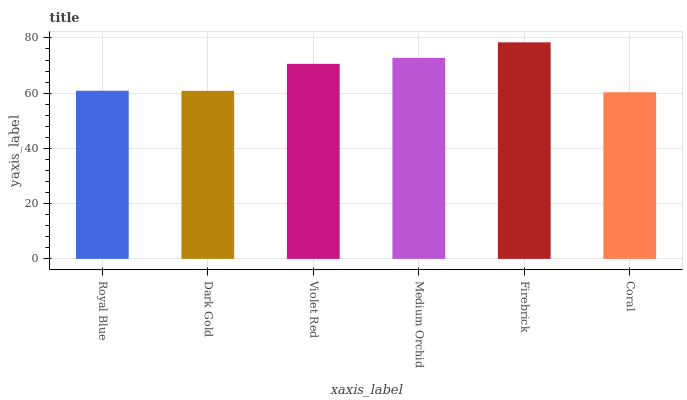Is Coral the minimum?
Answer yes or no. Yes. Is Firebrick the maximum?
Answer yes or no. Yes. Is Dark Gold the minimum?
Answer yes or no. No. Is Dark Gold the maximum?
Answer yes or no. No. Is Royal Blue greater than Dark Gold?
Answer yes or no. Yes. Is Dark Gold less than Royal Blue?
Answer yes or no. Yes. Is Dark Gold greater than Royal Blue?
Answer yes or no. No. Is Royal Blue less than Dark Gold?
Answer yes or no. No. Is Violet Red the high median?
Answer yes or no. Yes. Is Royal Blue the low median?
Answer yes or no. Yes. Is Coral the high median?
Answer yes or no. No. Is Medium Orchid the low median?
Answer yes or no. No. 